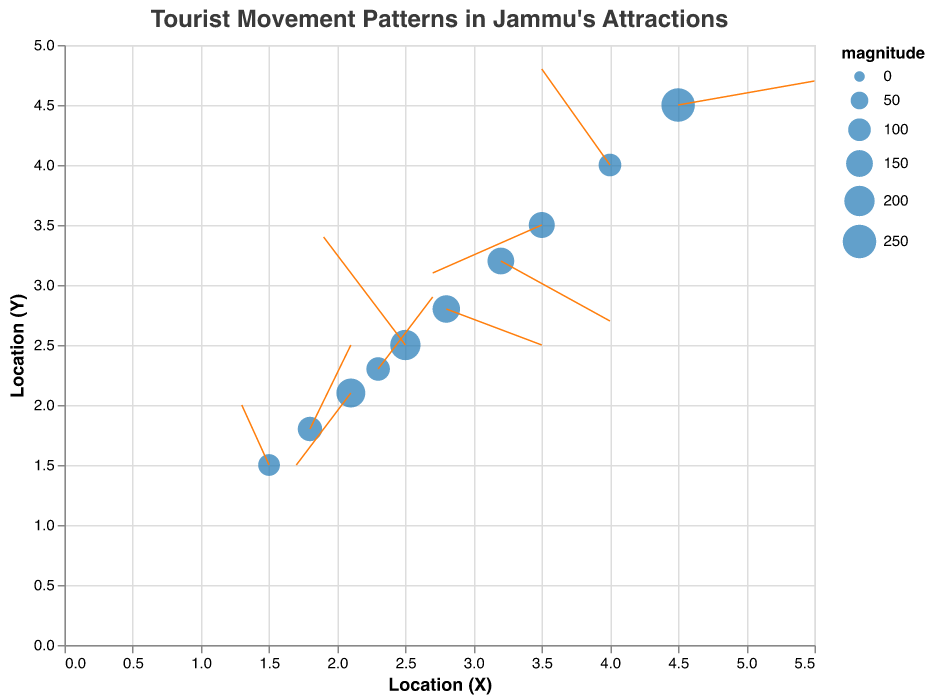How many popular attractions in Jammu are represented in the figure? Count the unique attraction names listed in the data. There are 10 unique attractions: Bahu Fort, Raghunath Temple, Amar Mahal Palace, Mubarak Mandi Complex, Mansar Lake, Surinsar Lake, Bagh-e-Bahu, Peer Kho Cave, Dogra Art Museum, and Mahamaya Temple.
Answer: 10 What is the title of the figure? Read the title at the top of the figure: "Tourist Movement Patterns in Jammu's Attractions."
Answer: Tourist Movement Patterns in Jammu's Attractions Which attraction has the highest tourist flow magnitude? Check the 'magnitude' values for each attraction. Mansar Lake has the highest magnitude value of 250.
Answer: Mansar Lake Which direction are tourists mostly moving near Amar Mahal Palace? Look at the direction indicated by the vectors (u, v) for Amar Mahal Palace. It shows a northern and eastern movement (u=0.3, v=0.7).
Answer: North-East What is the combined magnitude of tourist flow for Bahu Fort and Bagh-e-Bahu? Sum the magnitudes of Bahu Fort (150) and Bagh-e-Bahu (160). Total magnitude is 150 + 160 = 310.
Answer: 310 Compare the movement direction of tourists between Raghunath Temple and Mahamaya Temple. Which one shows a stronger eastward movement component? Compare the 'u' values for Raghunath Temple (-0.6) and Mahamaya Temple (-0.8). Raghunath Temple has a weaker eastward movement component as -0.6 is less negative than -0.8.
Answer: Raghunath Temple For which attraction do tourists show strong inward movement? Check the vectors indicating directions for an inward movement (negative u and v components). Mubarak Mandi Complex has inward movement with u=-0.4 and v=-0.6.
Answer: Mubarak Mandi Complex What is the size of the point representing Movement Patterns in Jammu's Attractions for the Dogra Art Museum? The size of the points is derived from magnitude field scaled between 50-500. Dogra Art Museum's magnitude is 110. The exact size calculation would depend on the scaling function defined in the visualization.
Answer: Based on magnitude of 110 Which two attractions are geographically closest on the plot? Visually inspecting the plot, Raghunath Temple and Mubarak Mandi Complex have the closest (x, y) coordinates (2.5, 2.5) and (2.1, 2.1) respectively.
Answer: Raghunath Temple and Mubarak Mandi Complex Does Mansar Lake show a net outward or inward tourist movement? Look at Mansar Lake's vector direction (u=1.0, v=0.2) which indicates an outward movement due to its positive components.
Answer: Outward 